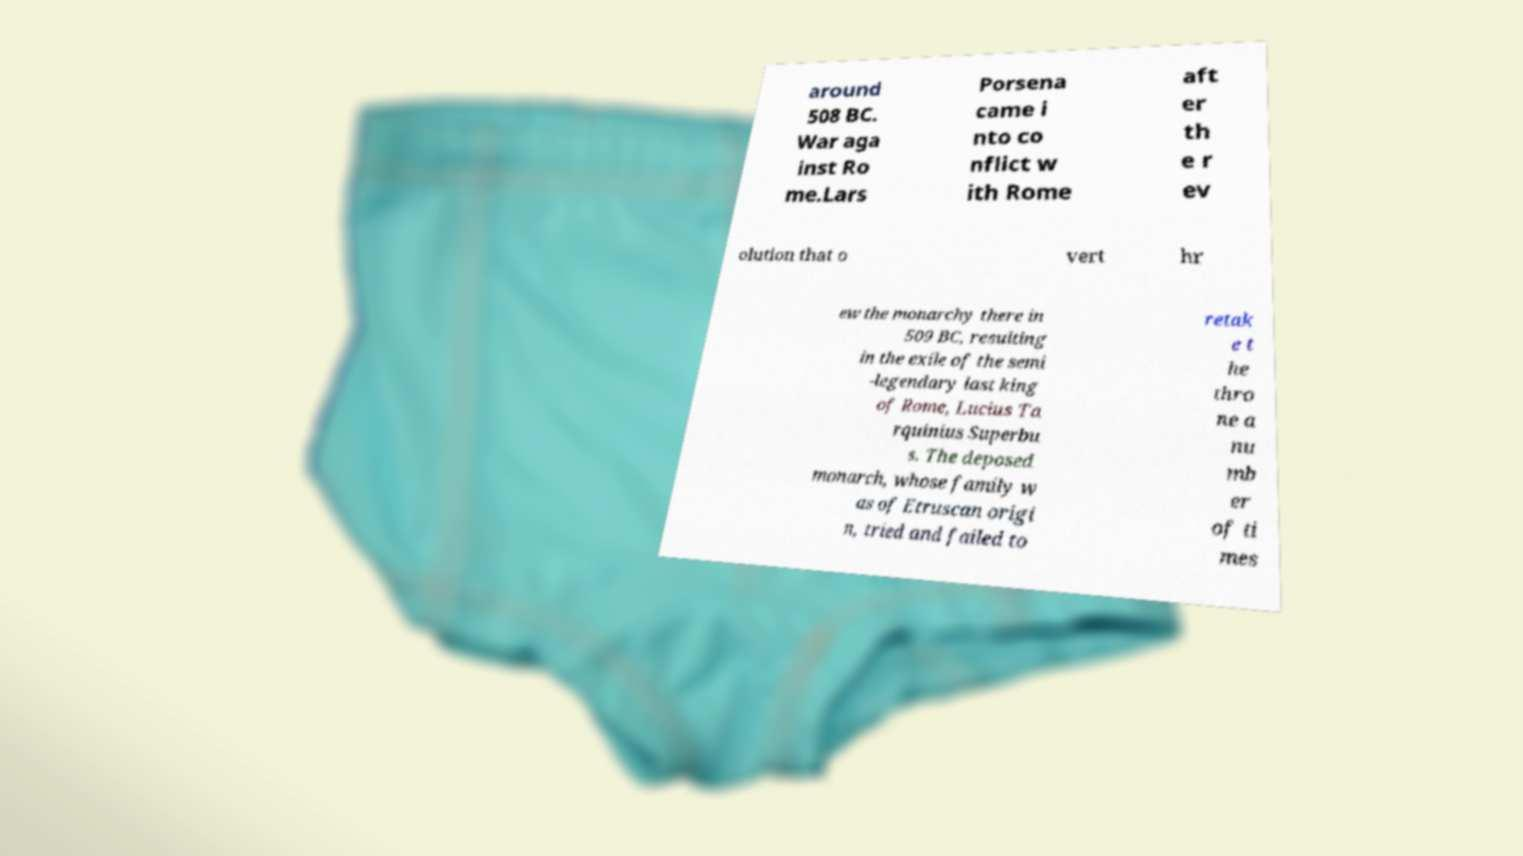What messages or text are displayed in this image? I need them in a readable, typed format. around 508 BC. War aga inst Ro me.Lars Porsena came i nto co nflict w ith Rome aft er th e r ev olution that o vert hr ew the monarchy there in 509 BC, resulting in the exile of the semi -legendary last king of Rome, Lucius Ta rquinius Superbu s. The deposed monarch, whose family w as of Etruscan origi n, tried and failed to retak e t he thro ne a nu mb er of ti mes 